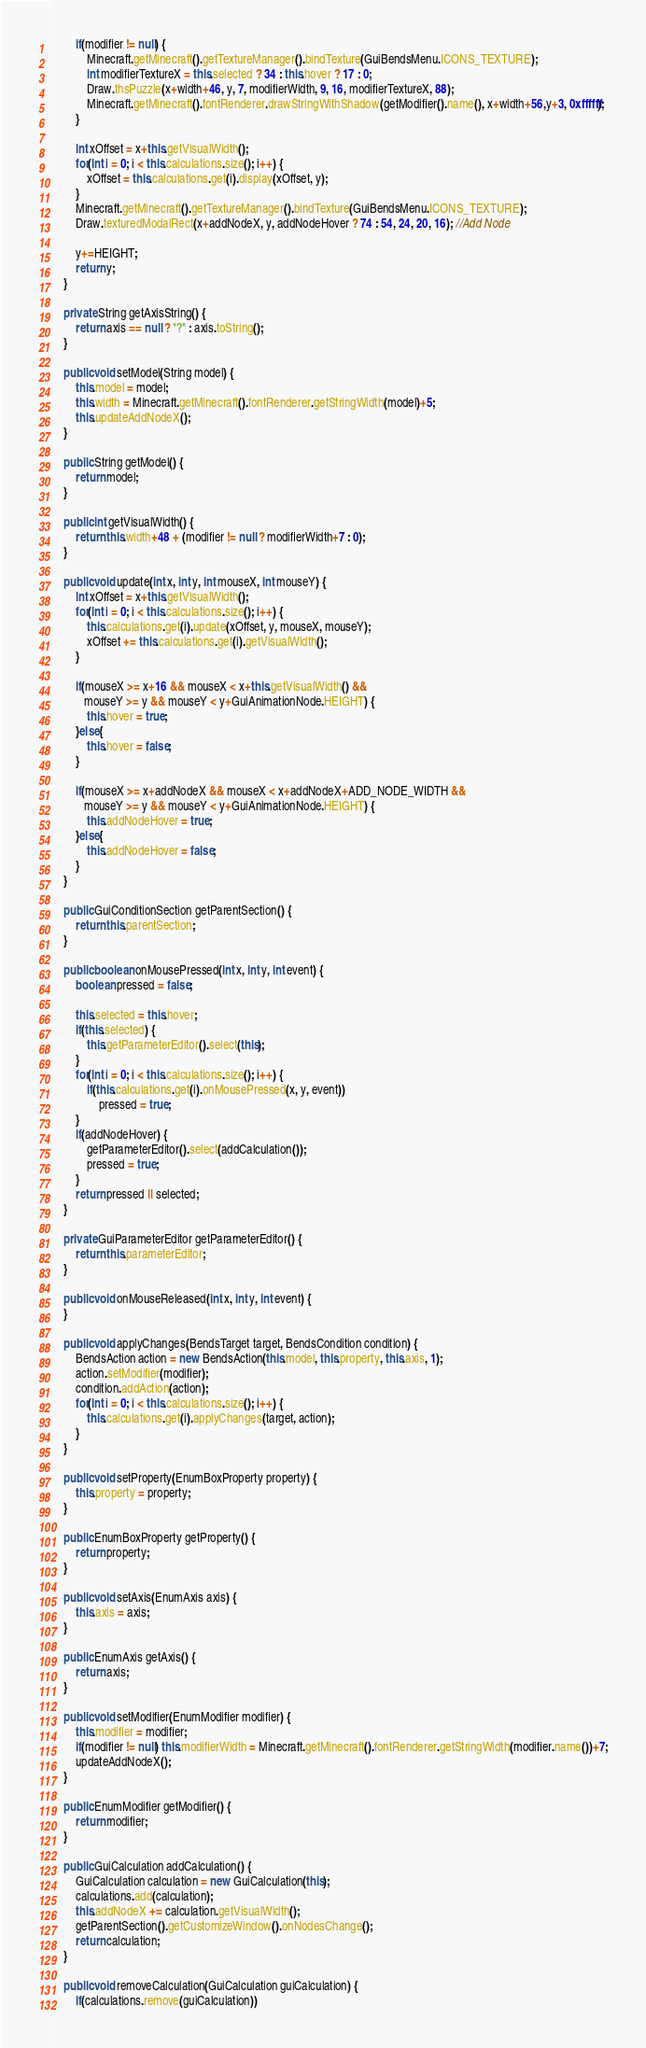<code> <loc_0><loc_0><loc_500><loc_500><_Java_>        if(modifier != null) {
        	Minecraft.getMinecraft().getTextureManager().bindTexture(GuiBendsMenu.ICONS_TEXTURE);
            int modifierTextureX = this.selected ? 34 : this.hover ? 17 : 0;
            Draw.thsPuzzle(x+width+46, y, 7, modifierWidth, 9, 16, modifierTextureX, 88);
            Minecraft.getMinecraft().fontRenderer.drawStringWithShadow(getModifier().name(), x+width+56,y+3, 0xffffff);
        }
        
        int xOffset = x+this.getVisualWidth();
        for(int i = 0; i < this.calculations.size(); i++) {
        	xOffset = this.calculations.get(i).display(xOffset, y);
        }
        Minecraft.getMinecraft().getTextureManager().bindTexture(GuiBendsMenu.ICONS_TEXTURE);
        Draw.texturedModalRect(x+addNodeX, y, addNodeHover ? 74 : 54, 24, 20, 16); //Add Node
        
        y+=HEIGHT;
		return y;
	}

	private String getAxisString() {
		return axis == null ? "?" : axis.toString();
	}

	public void setModel(String model) {
		this.model = model;
		this.width = Minecraft.getMinecraft().fontRenderer.getStringWidth(model)+5;
		this.updateAddNodeX();
	}
	
	public String getModel() {
		return model;
	}

	public int getVisualWidth() {
		return this.width+48 + (modifier != null ? modifierWidth+7 : 0);
	}
	
	public void update(int x, int y, int mouseX, int mouseY) {
		int xOffset = x+this.getVisualWidth();
		for(int i = 0; i < this.calculations.size(); i++) {
			this.calculations.get(i).update(xOffset, y, mouseX, mouseY);
			xOffset += this.calculations.get(i).getVisualWidth();
		}
		
		if(mouseX >= x+16 && mouseX < x+this.getVisualWidth() &&
		   mouseY >= y && mouseY < y+GuiAnimationNode.HEIGHT) {
			this.hover = true;
		}else{
			this.hover = false;
		}
		
		if(mouseX >= x+addNodeX && mouseX < x+addNodeX+ADD_NODE_WIDTH &&
		   mouseY >= y && mouseY < y+GuiAnimationNode.HEIGHT) {
			this.addNodeHover = true;
		}else{
			this.addNodeHover = false;
		}
	}
	
	public GuiConditionSection getParentSection() {
		return this.parentSection;
	}

	public boolean onMousePressed(int x, int y, int event) {
		boolean pressed = false;
		
		this.selected = this.hover;
		if(this.selected) {
			this.getParameterEditor().select(this);
		}
		for(int i = 0; i < this.calculations.size(); i++) {
			if(this.calculations.get(i).onMousePressed(x, y, event))
				pressed = true;
		}
		if(addNodeHover) {
			getParameterEditor().select(addCalculation());
			pressed = true;
		}
		return pressed || selected;
	}

	private GuiParameterEditor getParameterEditor() {
		return this.parameterEditor;
	}

	public void onMouseReleased(int x, int y, int event) {
	}

	public void applyChanges(BendsTarget target, BendsCondition condition) {
		BendsAction action = new BendsAction(this.model, this.property, this.axis, 1);
		action.setModifier(modifier);
		condition.addAction(action);
		for(int i = 0; i < this.calculations.size(); i++) {
			this.calculations.get(i).applyChanges(target, action);
		}
	}

	public void setProperty(EnumBoxProperty property) {
		this.property = property;
	}

	public EnumBoxProperty getProperty() {
		return property;
	}
	
	public void setAxis(EnumAxis axis) {
		this.axis = axis;
	}
	
	public EnumAxis getAxis() {
		return axis;
	}
	
	public void setModifier(EnumModifier modifier) {
		this.modifier = modifier;
		if(modifier != null) this.modifierWidth = Minecraft.getMinecraft().fontRenderer.getStringWidth(modifier.name())+7;
		updateAddNodeX();
	}
	
	public EnumModifier getModifier() {
		return modifier;
	}
	
	public GuiCalculation addCalculation() {
		GuiCalculation calculation = new GuiCalculation(this);
		calculations.add(calculation);
		this.addNodeX += calculation.getVisualWidth();
		getParentSection().getCustomizeWindow().onNodesChange();
		return calculation;
	}
	
	public void removeCalculation(GuiCalculation guiCalculation) {
		if(calculations.remove(guiCalculation))</code> 